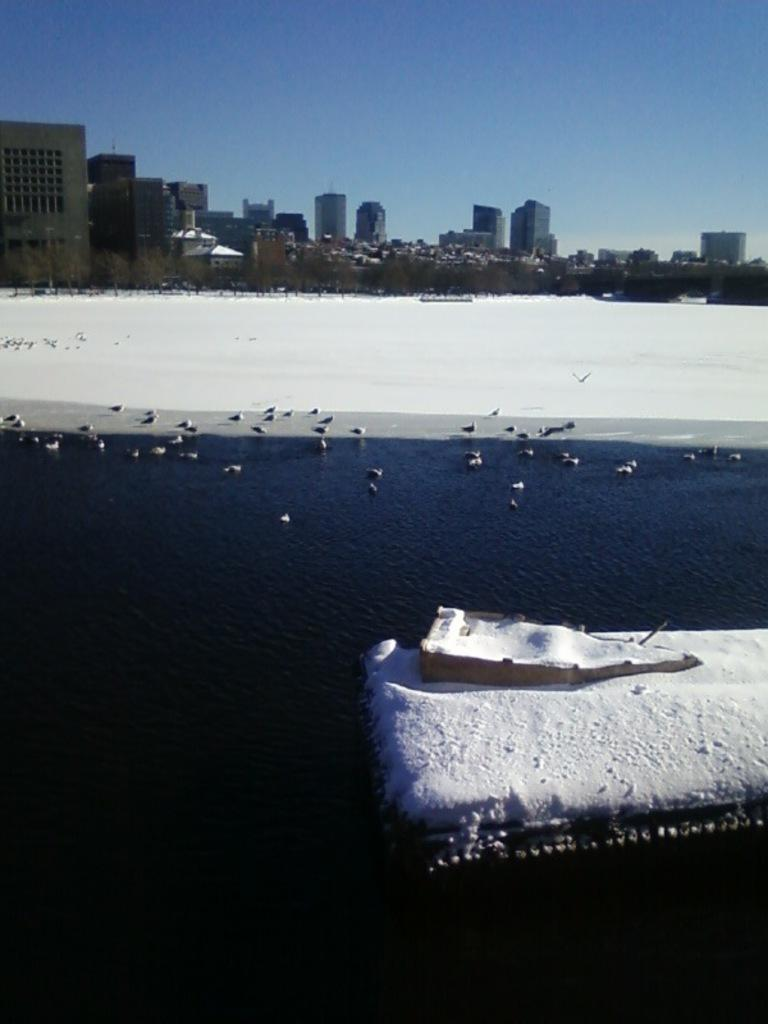What type of structures can be seen in the image? There are buildings in the image. What natural elements are present in the image? There are trees and snow visible in the image. What type of animals can be seen in the image? There are birds in the image. What type of landscape feature is visible in the image? There is water visible in the image. What is the object in front of the image? The object in front of the image has snow on it. What is the color of the sky in the image? The sky is blue and white in color. Can you tell me how many shades of green are present on the trees in the image? There is no mention of the number of shades of green on the trees in the image, nor is there any information about the trees' colors. How many toes can be seen on the birds in the image? There is no information about the birds' toes in the image, nor is there any indication that the birds have visible toes. 